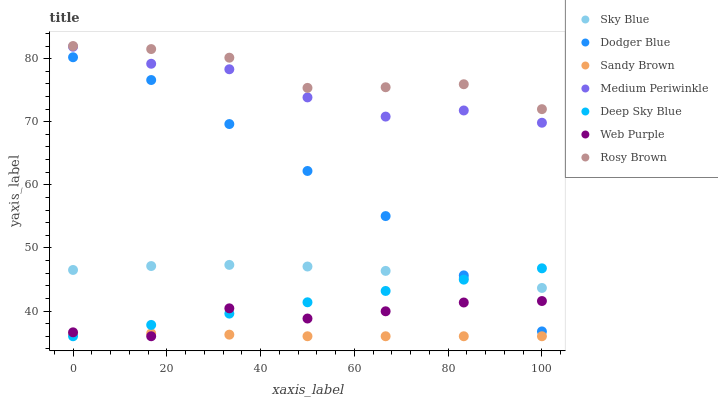Does Sandy Brown have the minimum area under the curve?
Answer yes or no. Yes. Does Rosy Brown have the maximum area under the curve?
Answer yes or no. Yes. Does Medium Periwinkle have the minimum area under the curve?
Answer yes or no. No. Does Medium Periwinkle have the maximum area under the curve?
Answer yes or no. No. Is Deep Sky Blue the smoothest?
Answer yes or no. Yes. Is Web Purple the roughest?
Answer yes or no. Yes. Is Medium Periwinkle the smoothest?
Answer yes or no. No. Is Medium Periwinkle the roughest?
Answer yes or no. No. Does Web Purple have the lowest value?
Answer yes or no. Yes. Does Medium Periwinkle have the lowest value?
Answer yes or no. No. Does Rosy Brown have the highest value?
Answer yes or no. Yes. Does Medium Periwinkle have the highest value?
Answer yes or no. No. Is Web Purple less than Medium Periwinkle?
Answer yes or no. Yes. Is Rosy Brown greater than Web Purple?
Answer yes or no. Yes. Does Sandy Brown intersect Deep Sky Blue?
Answer yes or no. Yes. Is Sandy Brown less than Deep Sky Blue?
Answer yes or no. No. Is Sandy Brown greater than Deep Sky Blue?
Answer yes or no. No. Does Web Purple intersect Medium Periwinkle?
Answer yes or no. No. 